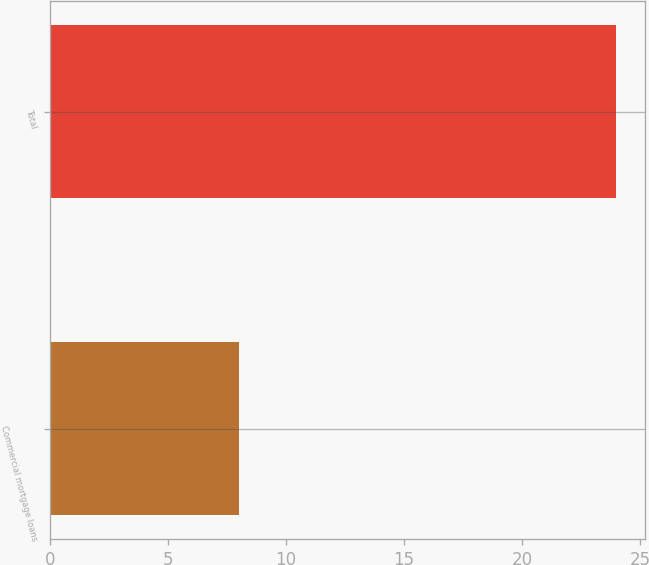Convert chart to OTSL. <chart><loc_0><loc_0><loc_500><loc_500><bar_chart><fcel>Commercial mortgage loans<fcel>Total<nl><fcel>8<fcel>24<nl></chart> 